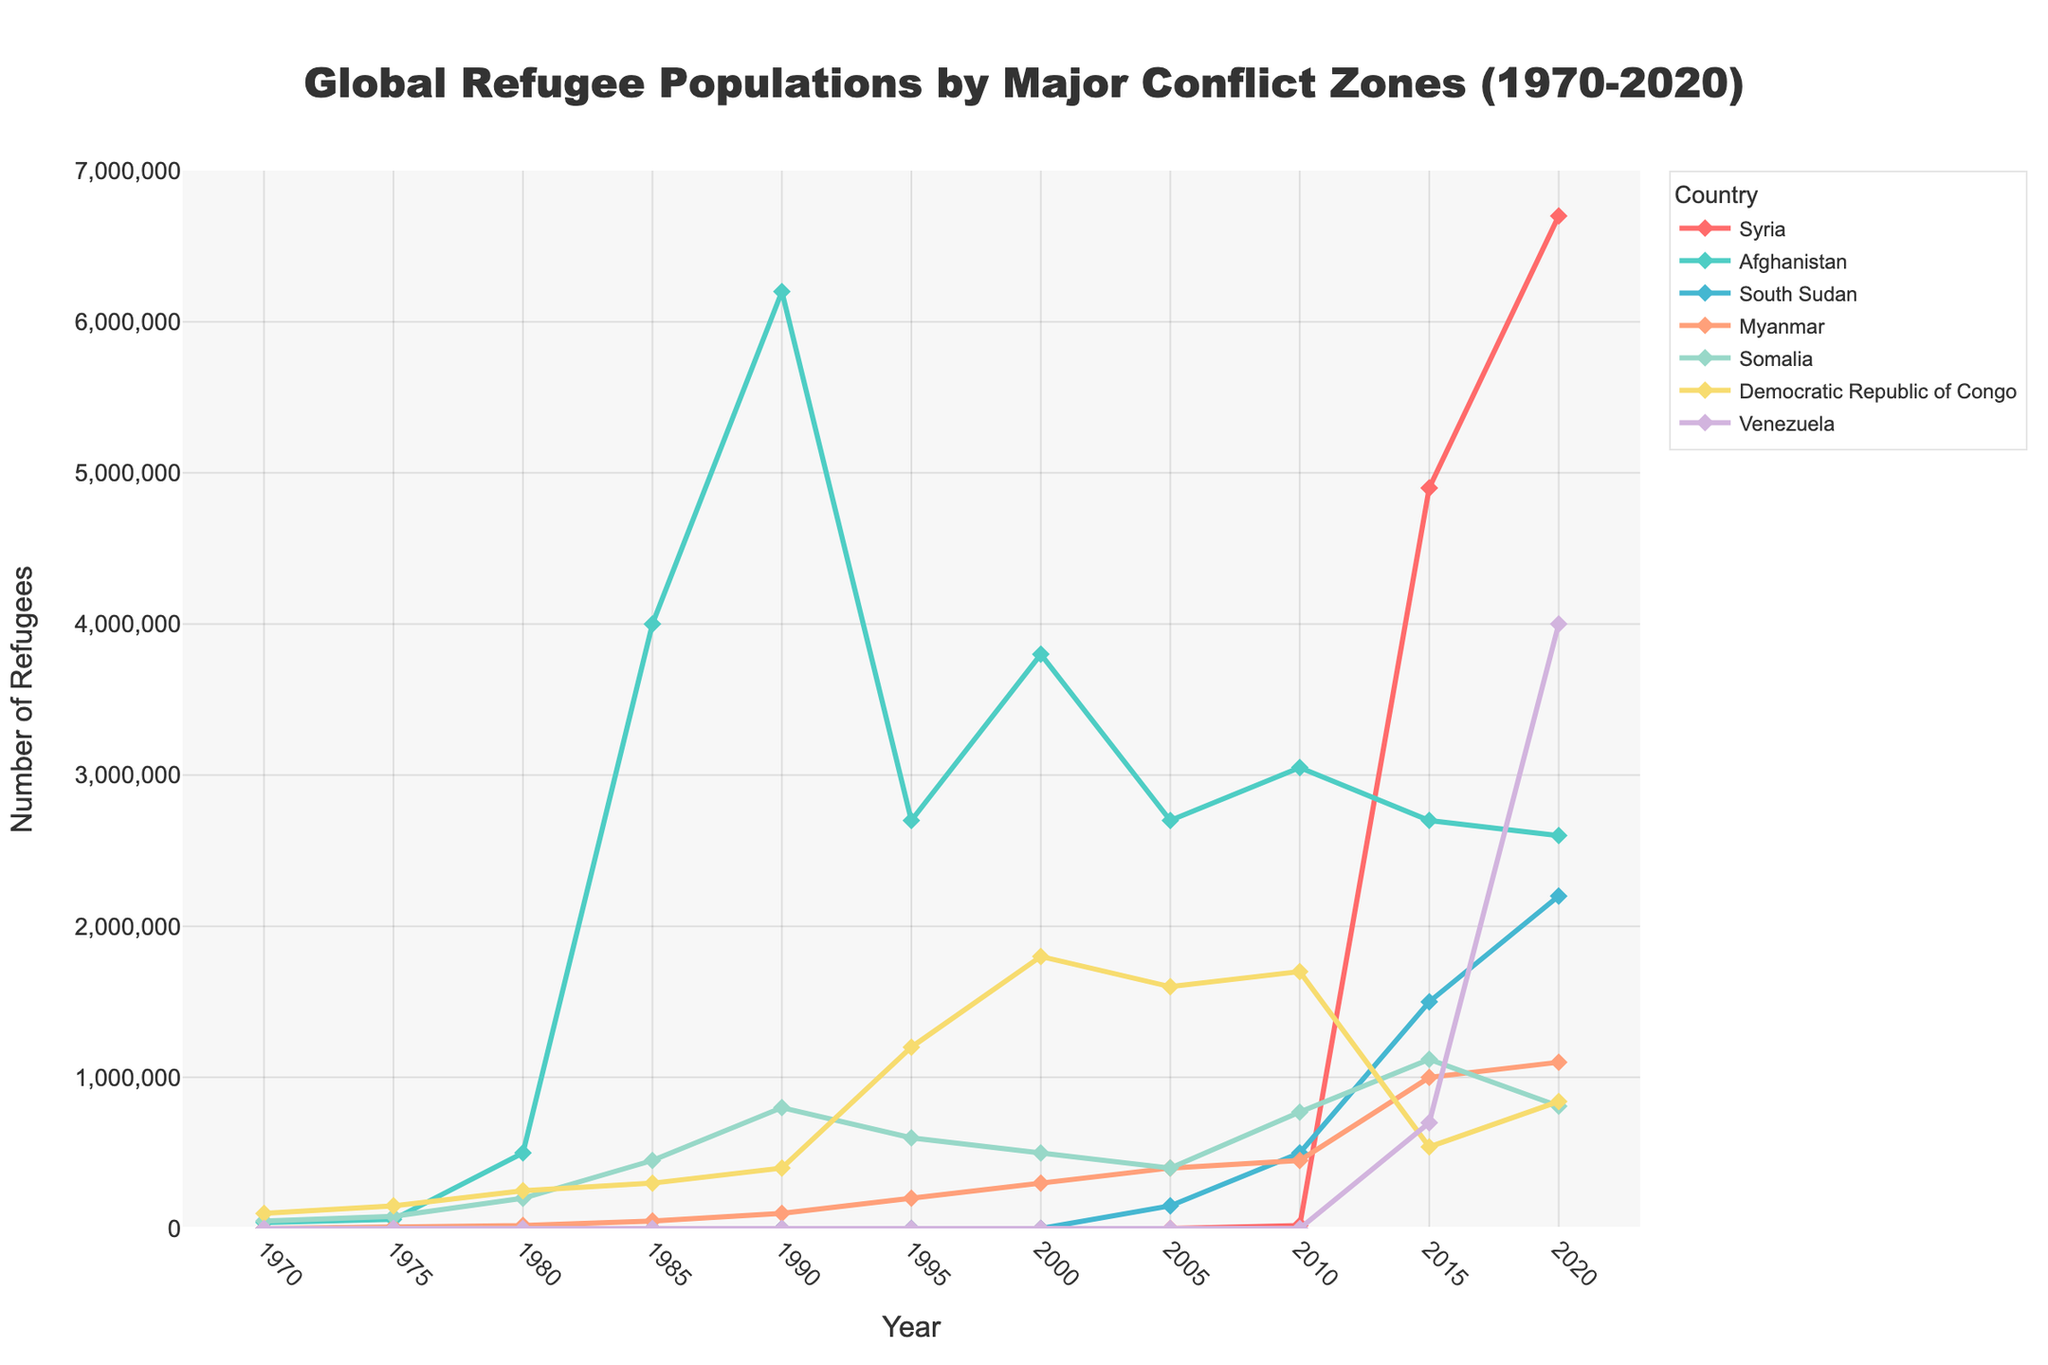What is the general trend of refugee populations for Syria from 2010 to 2020? The refugee population from Syria shows a rising trend from 2010 (20,000) to 2020 (6,700,000). This can be seen by observing the increasing line for Syria over these years.
Answer: Increasing Which country had the highest refugee population in 1990? By looking at the lines in the figure, the line representing Afghanistan is the highest in 1990 with 6,200,000 refugees.
Answer: Afghanistan Compare the refugee populations of South Sudan and Myanmar in 2015. Which country had more refugees? In 2015, South Sudan had 1,500,000 refugees, while Myanmar had 1,000,000 refugees. By comparing these numbers, South Sudan had more refugees.
Answer: South Sudan Which conflict zone shows a significant increase in refugee population between 2015 and 2020? Venezuela shows a significant increase in the refugee population from 700,000 in 2015 to 4,000,000 in 2020. This is visible by the sharp upward slope of the line representing Venezuela during these years.
Answer: Venezuela What is the sum of Refugees from Syria, Afghanistan, and South Sudan in 2020? Adding the populations from the figure for 2020: Syria: 6,700,000, Afghanistan: 2,600,000, South Sudan: 2,200,000. Summing these gives 6,700,000 + 2,600,000 + 2,200,000 = 11,500,000.
Answer: 11,500,000 What period saw the highest refugee population from the Democratic Republic of Congo (DRC)? The highest refugee population for the DRC is observed in 2000 with 1,800,000 refugees. This is identified by the DRC line peaking at 2000.
Answer: 2000 In what year did Somalia see a peak in its refugee population, and what was the population size? According to the figure, Somalia peaked in 2015 with a population of 1,120,000 refugees. This can be seen by identifying the highest point on the Somalia line and its corresponding year.
Answer: 2015, 1,120,000 How did the refugee population from Myanmar change between 1975 and 1985, measured by its initial and final values? In 1975, Myanmar had 10,000 refugees, and by 1985, it increased to 50,000. The change in population is calculated as 50,000 - 10,000 = 40,000.
Answer: Increased by 40,000 What are the visual indications that Syria’s refugee population significantly surged after 2010? The line representing Syria dramatically rises after 2010, marked by a steep upward slope, indicating a significant surge in refugee numbers.
Answer: Steep upward slope 